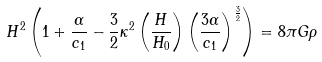Convert formula to latex. <formula><loc_0><loc_0><loc_500><loc_500>H ^ { 2 } \left ( 1 + \frac { \alpha } { c _ { 1 } } - \frac { 3 } { 2 } \kappa ^ { 2 } \left ( \frac { H } { H _ { 0 } } \right ) \left ( \frac { 3 \alpha } { c _ { 1 } } \right ) ^ { \frac { 3 } { 2 } } \right ) = 8 \pi G \rho</formula> 